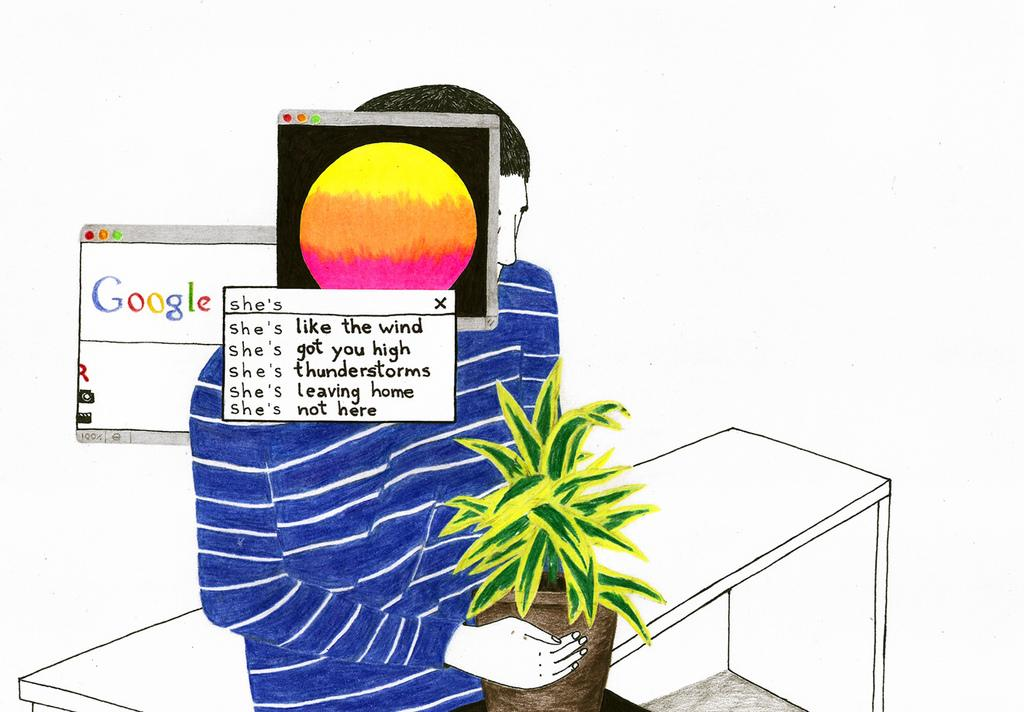What type of image is being described? The image is animated. What is the person in the image doing? The person is sitting on a table. What is the person holding in the image? The person is holding a plant. How many pop-up windows are in front of the man's face? There are three pop-up windows in front of the man's face. Is there a baby sitting next to the person holding the plant in the image? There is no baby present in the image; it only features a person sitting on a table holding a plant and three pop-up windows in front of the man's face. 